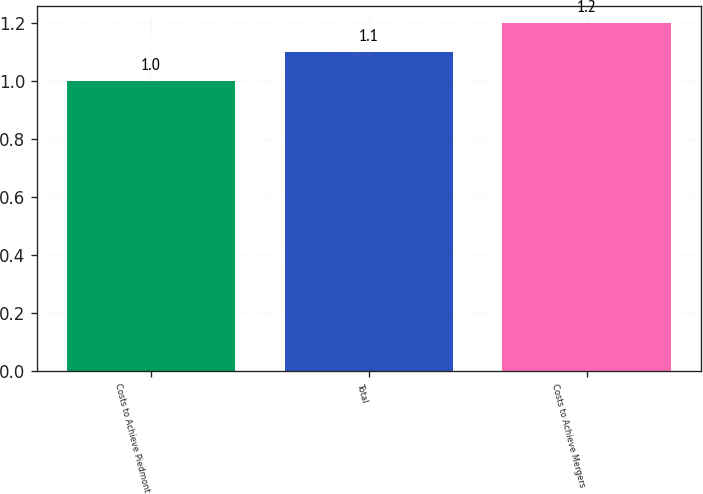<chart> <loc_0><loc_0><loc_500><loc_500><bar_chart><fcel>Costs to Achieve Piedmont<fcel>Total<fcel>Costs to Achieve Mergers<nl><fcel>1<fcel>1.1<fcel>1.2<nl></chart> 